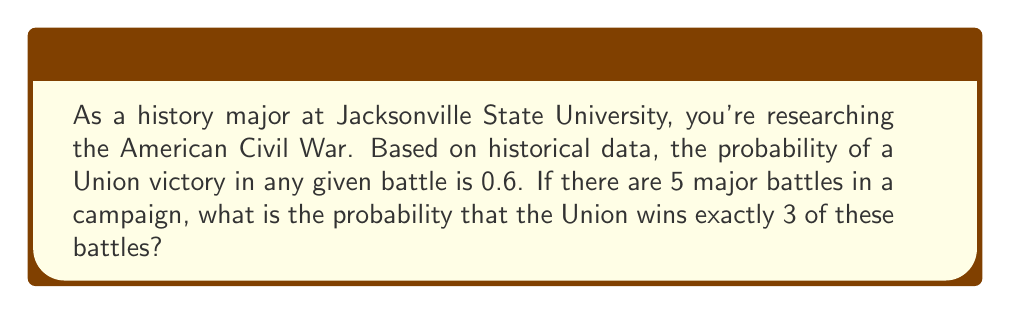Teach me how to tackle this problem. To solve this problem, we'll use the binomial probability formula, as we're dealing with a fixed number of independent trials (battles) with two possible outcomes (Union victory or defeat) and a constant probability of success.

The binomial probability formula is:

$$P(X = k) = \binom{n}{k} p^k (1-p)^{n-k}$$

Where:
$n$ = number of trials (battles)
$k$ = number of successes (Union victories)
$p$ = probability of success on each trial

Given:
$n = 5$ (5 major battles)
$k = 3$ (exactly 3 Union victories)
$p = 0.6$ (probability of Union victory in any battle)

Step 1: Calculate the binomial coefficient $\binom{n}{k}$
$$\binom{5}{3} = \frac{5!}{3!(5-3)!} = \frac{5 \cdot 4}{2 \cdot 1} = 10$$

Step 2: Calculate $p^k$
$$0.6^3 = 0.216$$

Step 3: Calculate $(1-p)^{n-k}$
$$(1-0.6)^{5-3} = 0.4^2 = 0.16$$

Step 4: Multiply all components
$$10 \cdot 0.216 \cdot 0.16 = 0.3456$$

Therefore, the probability of the Union winning exactly 3 out of 5 major battles is 0.3456 or about 34.56%.
Answer: $0.3456$ or $34.56\%$ 